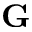<formula> <loc_0><loc_0><loc_500><loc_500>G</formula> 